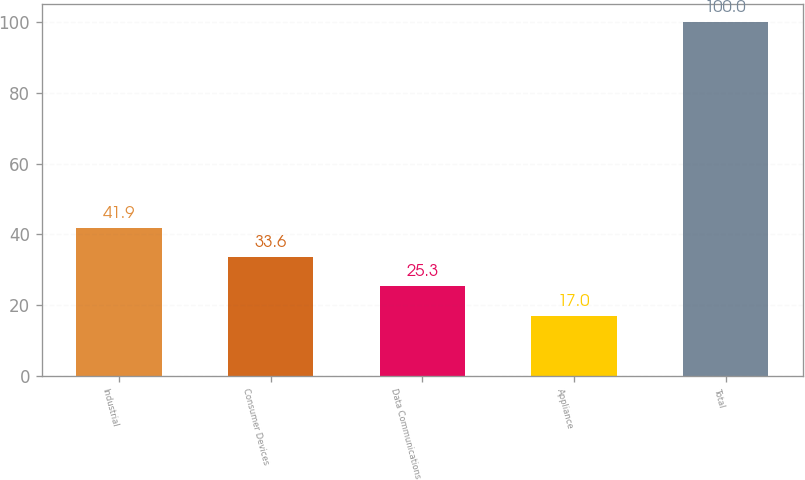Convert chart. <chart><loc_0><loc_0><loc_500><loc_500><bar_chart><fcel>Industrial<fcel>Consumer Devices<fcel>Data Communications<fcel>Appliance<fcel>Total<nl><fcel>41.9<fcel>33.6<fcel>25.3<fcel>17<fcel>100<nl></chart> 